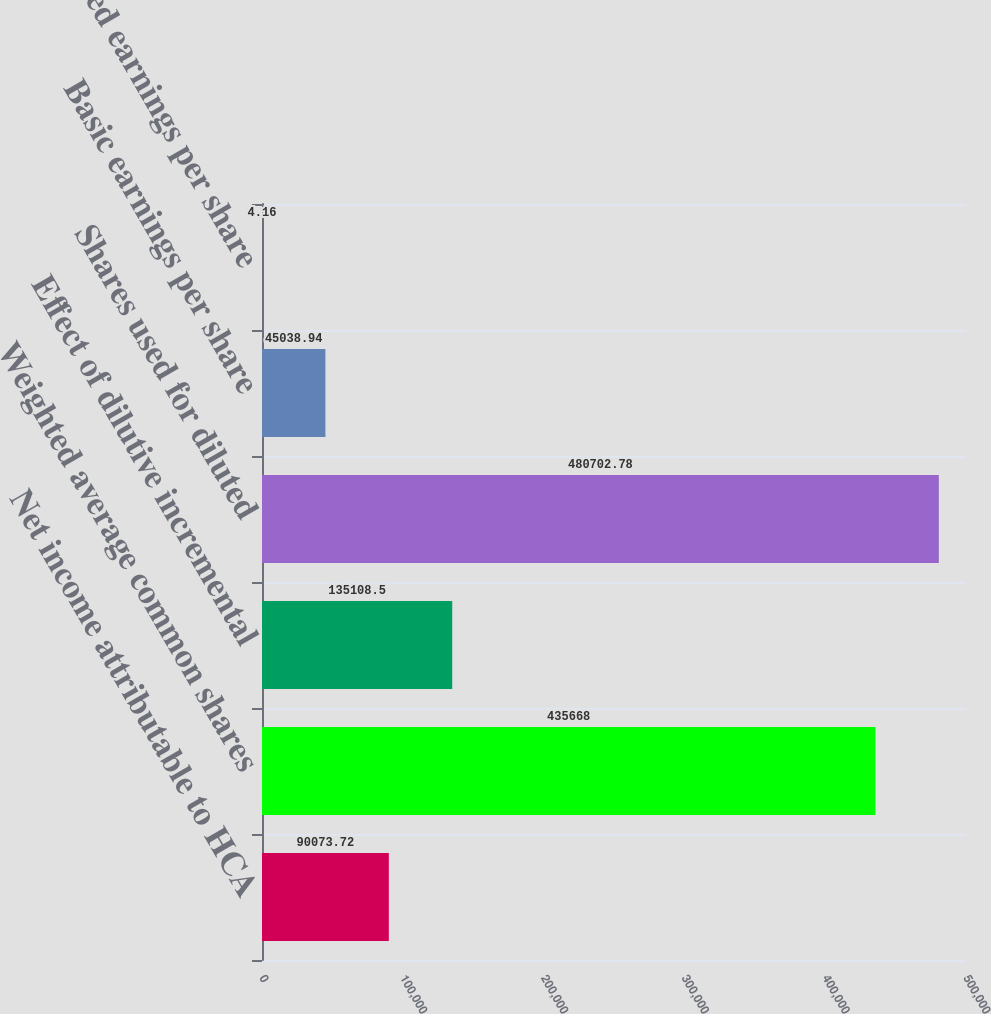Convert chart to OTSL. <chart><loc_0><loc_0><loc_500><loc_500><bar_chart><fcel>Net income attributable to HCA<fcel>Weighted average common shares<fcel>Effect of dilutive incremental<fcel>Shares used for diluted<fcel>Basic earnings per share<fcel>Diluted earnings per share<nl><fcel>90073.7<fcel>435668<fcel>135108<fcel>480703<fcel>45038.9<fcel>4.16<nl></chart> 